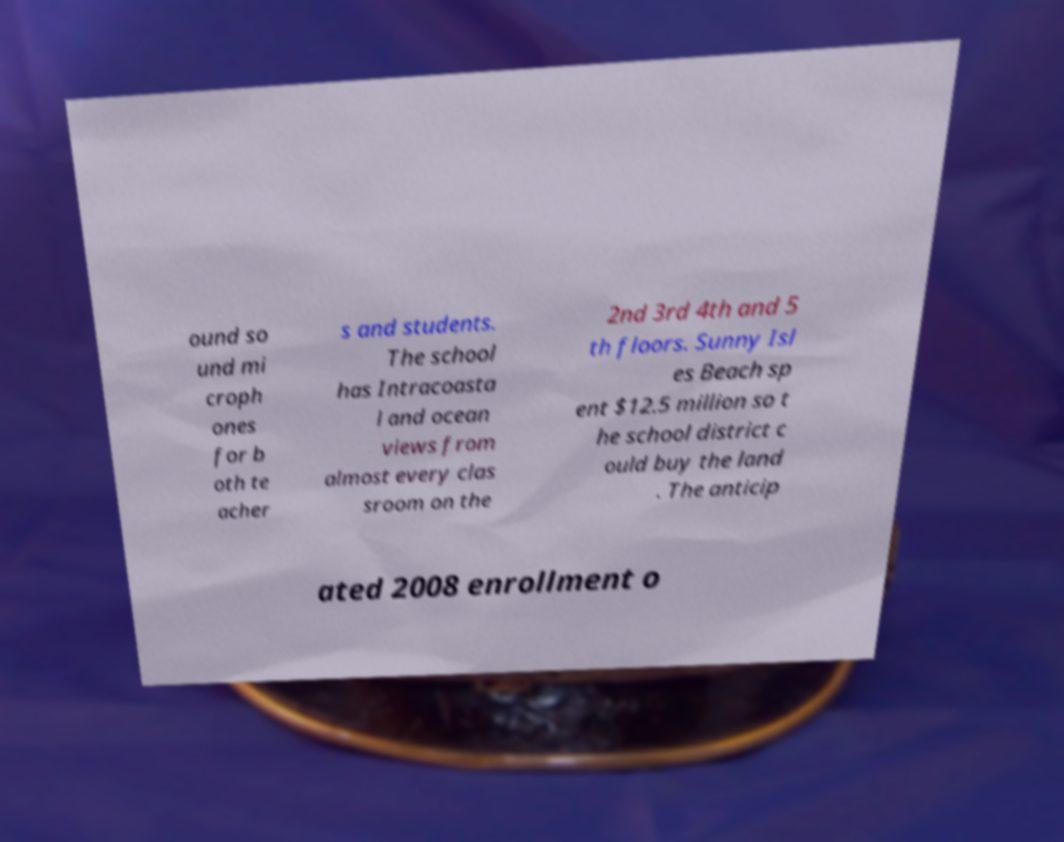What messages or text are displayed in this image? I need them in a readable, typed format. ound so und mi croph ones for b oth te acher s and students. The school has Intracoasta l and ocean views from almost every clas sroom on the 2nd 3rd 4th and 5 th floors. Sunny Isl es Beach sp ent $12.5 million so t he school district c ould buy the land . The anticip ated 2008 enrollment o 